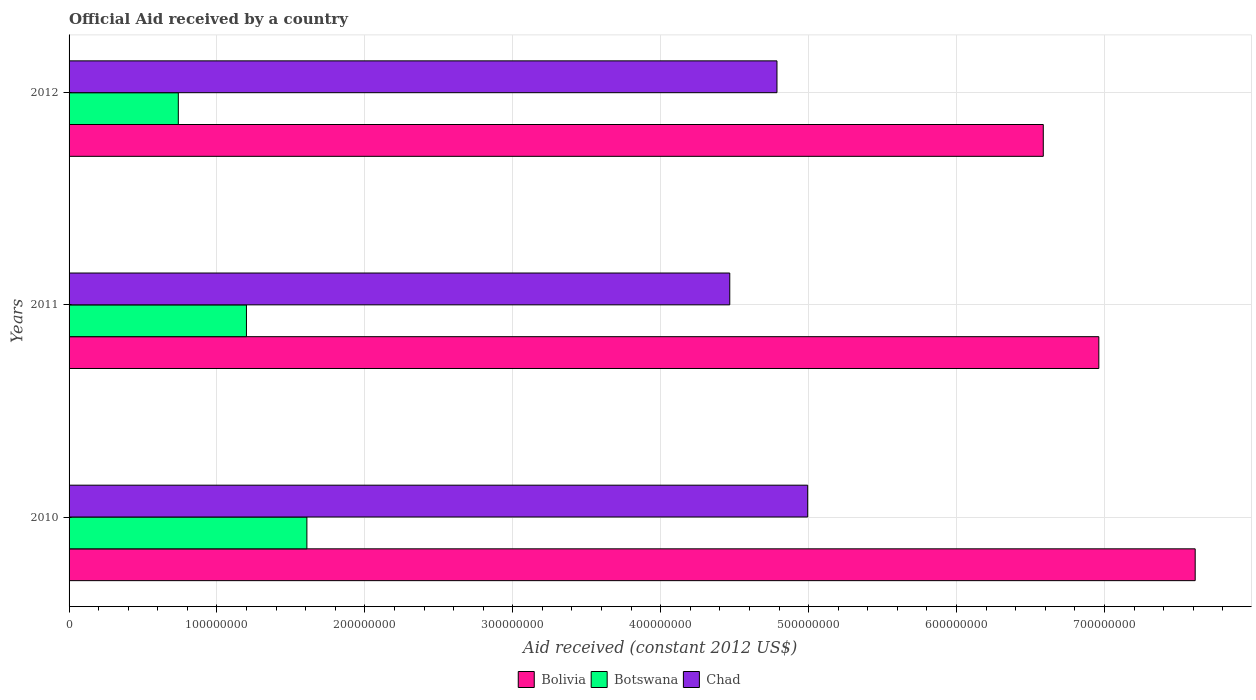Are the number of bars on each tick of the Y-axis equal?
Provide a succinct answer. Yes. How many bars are there on the 2nd tick from the bottom?
Keep it short and to the point. 3. What is the label of the 2nd group of bars from the top?
Make the answer very short. 2011. In how many cases, is the number of bars for a given year not equal to the number of legend labels?
Offer a very short reply. 0. What is the net official aid received in Bolivia in 2011?
Ensure brevity in your answer.  6.96e+08. Across all years, what is the maximum net official aid received in Botswana?
Your response must be concise. 1.61e+08. Across all years, what is the minimum net official aid received in Bolivia?
Provide a succinct answer. 6.59e+08. What is the total net official aid received in Botswana in the graph?
Offer a terse response. 3.55e+08. What is the difference between the net official aid received in Bolivia in 2010 and that in 2012?
Ensure brevity in your answer.  1.03e+08. What is the difference between the net official aid received in Bolivia in 2010 and the net official aid received in Botswana in 2012?
Give a very brief answer. 6.87e+08. What is the average net official aid received in Bolivia per year?
Make the answer very short. 7.05e+08. In the year 2012, what is the difference between the net official aid received in Bolivia and net official aid received in Chad?
Your answer should be compact. 1.80e+08. In how many years, is the net official aid received in Botswana greater than 340000000 US$?
Provide a short and direct response. 0. What is the ratio of the net official aid received in Botswana in 2011 to that in 2012?
Offer a very short reply. 1.62. What is the difference between the highest and the second highest net official aid received in Bolivia?
Ensure brevity in your answer.  6.52e+07. What is the difference between the highest and the lowest net official aid received in Chad?
Keep it short and to the point. 5.27e+07. What does the 2nd bar from the bottom in 2010 represents?
Make the answer very short. Botswana. What is the difference between two consecutive major ticks on the X-axis?
Make the answer very short. 1.00e+08. Are the values on the major ticks of X-axis written in scientific E-notation?
Your response must be concise. No. Where does the legend appear in the graph?
Your response must be concise. Bottom center. How many legend labels are there?
Your response must be concise. 3. What is the title of the graph?
Make the answer very short. Official Aid received by a country. What is the label or title of the X-axis?
Keep it short and to the point. Aid received (constant 2012 US$). What is the label or title of the Y-axis?
Offer a very short reply. Years. What is the Aid received (constant 2012 US$) in Bolivia in 2010?
Offer a very short reply. 7.61e+08. What is the Aid received (constant 2012 US$) in Botswana in 2010?
Your answer should be compact. 1.61e+08. What is the Aid received (constant 2012 US$) of Chad in 2010?
Your answer should be very brief. 4.99e+08. What is the Aid received (constant 2012 US$) of Bolivia in 2011?
Give a very brief answer. 6.96e+08. What is the Aid received (constant 2012 US$) of Botswana in 2011?
Provide a succinct answer. 1.20e+08. What is the Aid received (constant 2012 US$) of Chad in 2011?
Provide a succinct answer. 4.47e+08. What is the Aid received (constant 2012 US$) in Bolivia in 2012?
Your answer should be very brief. 6.59e+08. What is the Aid received (constant 2012 US$) in Botswana in 2012?
Keep it short and to the point. 7.39e+07. What is the Aid received (constant 2012 US$) in Chad in 2012?
Provide a succinct answer. 4.79e+08. Across all years, what is the maximum Aid received (constant 2012 US$) of Bolivia?
Ensure brevity in your answer.  7.61e+08. Across all years, what is the maximum Aid received (constant 2012 US$) of Botswana?
Offer a very short reply. 1.61e+08. Across all years, what is the maximum Aid received (constant 2012 US$) of Chad?
Keep it short and to the point. 4.99e+08. Across all years, what is the minimum Aid received (constant 2012 US$) of Bolivia?
Your answer should be compact. 6.59e+08. Across all years, what is the minimum Aid received (constant 2012 US$) in Botswana?
Make the answer very short. 7.39e+07. Across all years, what is the minimum Aid received (constant 2012 US$) in Chad?
Make the answer very short. 4.47e+08. What is the total Aid received (constant 2012 US$) in Bolivia in the graph?
Provide a short and direct response. 2.12e+09. What is the total Aid received (constant 2012 US$) of Botswana in the graph?
Offer a very short reply. 3.55e+08. What is the total Aid received (constant 2012 US$) in Chad in the graph?
Make the answer very short. 1.42e+09. What is the difference between the Aid received (constant 2012 US$) of Bolivia in 2010 and that in 2011?
Your response must be concise. 6.52e+07. What is the difference between the Aid received (constant 2012 US$) of Botswana in 2010 and that in 2011?
Provide a short and direct response. 4.09e+07. What is the difference between the Aid received (constant 2012 US$) of Chad in 2010 and that in 2011?
Your response must be concise. 5.27e+07. What is the difference between the Aid received (constant 2012 US$) in Bolivia in 2010 and that in 2012?
Offer a terse response. 1.03e+08. What is the difference between the Aid received (constant 2012 US$) in Botswana in 2010 and that in 2012?
Make the answer very short. 8.69e+07. What is the difference between the Aid received (constant 2012 US$) in Chad in 2010 and that in 2012?
Offer a very short reply. 2.08e+07. What is the difference between the Aid received (constant 2012 US$) of Bolivia in 2011 and that in 2012?
Provide a short and direct response. 3.76e+07. What is the difference between the Aid received (constant 2012 US$) in Botswana in 2011 and that in 2012?
Give a very brief answer. 4.61e+07. What is the difference between the Aid received (constant 2012 US$) of Chad in 2011 and that in 2012?
Your answer should be very brief. -3.19e+07. What is the difference between the Aid received (constant 2012 US$) in Bolivia in 2010 and the Aid received (constant 2012 US$) in Botswana in 2011?
Make the answer very short. 6.41e+08. What is the difference between the Aid received (constant 2012 US$) of Bolivia in 2010 and the Aid received (constant 2012 US$) of Chad in 2011?
Offer a terse response. 3.15e+08. What is the difference between the Aid received (constant 2012 US$) of Botswana in 2010 and the Aid received (constant 2012 US$) of Chad in 2011?
Keep it short and to the point. -2.86e+08. What is the difference between the Aid received (constant 2012 US$) in Bolivia in 2010 and the Aid received (constant 2012 US$) in Botswana in 2012?
Provide a short and direct response. 6.87e+08. What is the difference between the Aid received (constant 2012 US$) in Bolivia in 2010 and the Aid received (constant 2012 US$) in Chad in 2012?
Make the answer very short. 2.83e+08. What is the difference between the Aid received (constant 2012 US$) in Botswana in 2010 and the Aid received (constant 2012 US$) in Chad in 2012?
Your answer should be very brief. -3.18e+08. What is the difference between the Aid received (constant 2012 US$) in Bolivia in 2011 and the Aid received (constant 2012 US$) in Botswana in 2012?
Ensure brevity in your answer.  6.22e+08. What is the difference between the Aid received (constant 2012 US$) in Bolivia in 2011 and the Aid received (constant 2012 US$) in Chad in 2012?
Your answer should be very brief. 2.18e+08. What is the difference between the Aid received (constant 2012 US$) in Botswana in 2011 and the Aid received (constant 2012 US$) in Chad in 2012?
Your response must be concise. -3.59e+08. What is the average Aid received (constant 2012 US$) in Bolivia per year?
Ensure brevity in your answer.  7.05e+08. What is the average Aid received (constant 2012 US$) of Botswana per year?
Ensure brevity in your answer.  1.18e+08. What is the average Aid received (constant 2012 US$) of Chad per year?
Your answer should be compact. 4.75e+08. In the year 2010, what is the difference between the Aid received (constant 2012 US$) in Bolivia and Aid received (constant 2012 US$) in Botswana?
Make the answer very short. 6.01e+08. In the year 2010, what is the difference between the Aid received (constant 2012 US$) of Bolivia and Aid received (constant 2012 US$) of Chad?
Provide a succinct answer. 2.62e+08. In the year 2010, what is the difference between the Aid received (constant 2012 US$) of Botswana and Aid received (constant 2012 US$) of Chad?
Give a very brief answer. -3.39e+08. In the year 2011, what is the difference between the Aid received (constant 2012 US$) in Bolivia and Aid received (constant 2012 US$) in Botswana?
Keep it short and to the point. 5.76e+08. In the year 2011, what is the difference between the Aid received (constant 2012 US$) in Bolivia and Aid received (constant 2012 US$) in Chad?
Your response must be concise. 2.50e+08. In the year 2011, what is the difference between the Aid received (constant 2012 US$) in Botswana and Aid received (constant 2012 US$) in Chad?
Provide a succinct answer. -3.27e+08. In the year 2012, what is the difference between the Aid received (constant 2012 US$) in Bolivia and Aid received (constant 2012 US$) in Botswana?
Offer a terse response. 5.85e+08. In the year 2012, what is the difference between the Aid received (constant 2012 US$) of Bolivia and Aid received (constant 2012 US$) of Chad?
Make the answer very short. 1.80e+08. In the year 2012, what is the difference between the Aid received (constant 2012 US$) of Botswana and Aid received (constant 2012 US$) of Chad?
Provide a short and direct response. -4.05e+08. What is the ratio of the Aid received (constant 2012 US$) in Bolivia in 2010 to that in 2011?
Keep it short and to the point. 1.09. What is the ratio of the Aid received (constant 2012 US$) in Botswana in 2010 to that in 2011?
Keep it short and to the point. 1.34. What is the ratio of the Aid received (constant 2012 US$) of Chad in 2010 to that in 2011?
Your answer should be compact. 1.12. What is the ratio of the Aid received (constant 2012 US$) in Bolivia in 2010 to that in 2012?
Ensure brevity in your answer.  1.16. What is the ratio of the Aid received (constant 2012 US$) in Botswana in 2010 to that in 2012?
Your answer should be very brief. 2.18. What is the ratio of the Aid received (constant 2012 US$) of Chad in 2010 to that in 2012?
Your answer should be very brief. 1.04. What is the ratio of the Aid received (constant 2012 US$) of Bolivia in 2011 to that in 2012?
Offer a very short reply. 1.06. What is the ratio of the Aid received (constant 2012 US$) of Botswana in 2011 to that in 2012?
Give a very brief answer. 1.62. What is the ratio of the Aid received (constant 2012 US$) in Chad in 2011 to that in 2012?
Keep it short and to the point. 0.93. What is the difference between the highest and the second highest Aid received (constant 2012 US$) of Bolivia?
Provide a short and direct response. 6.52e+07. What is the difference between the highest and the second highest Aid received (constant 2012 US$) of Botswana?
Offer a terse response. 4.09e+07. What is the difference between the highest and the second highest Aid received (constant 2012 US$) in Chad?
Offer a very short reply. 2.08e+07. What is the difference between the highest and the lowest Aid received (constant 2012 US$) of Bolivia?
Your answer should be compact. 1.03e+08. What is the difference between the highest and the lowest Aid received (constant 2012 US$) in Botswana?
Your answer should be compact. 8.69e+07. What is the difference between the highest and the lowest Aid received (constant 2012 US$) in Chad?
Make the answer very short. 5.27e+07. 